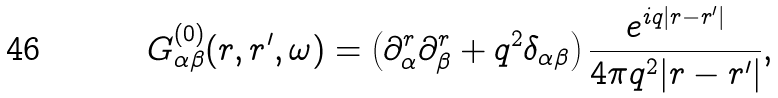<formula> <loc_0><loc_0><loc_500><loc_500>G ^ { ( 0 ) } _ { \alpha \beta } ( r , r ^ { \prime } , \omega ) = \left ( \partial ^ { r } _ { \alpha } \partial ^ { r } _ { \beta } + q ^ { 2 } \delta _ { \alpha \beta } \right ) \frac { e ^ { i q | r - r ^ { \prime } | } } { 4 \pi q ^ { 2 } | r - r ^ { \prime } | } ,</formula> 